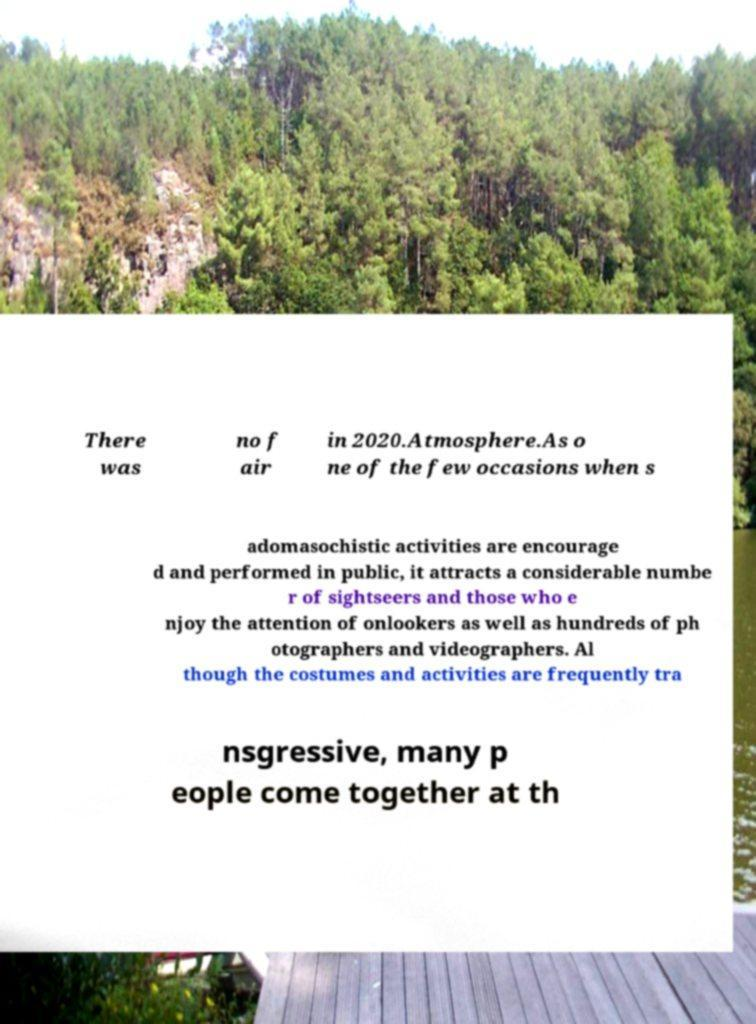Please identify and transcribe the text found in this image. There was no f air in 2020.Atmosphere.As o ne of the few occasions when s adomasochistic activities are encourage d and performed in public, it attracts a considerable numbe r of sightseers and those who e njoy the attention of onlookers as well as hundreds of ph otographers and videographers. Al though the costumes and activities are frequently tra nsgressive, many p eople come together at th 